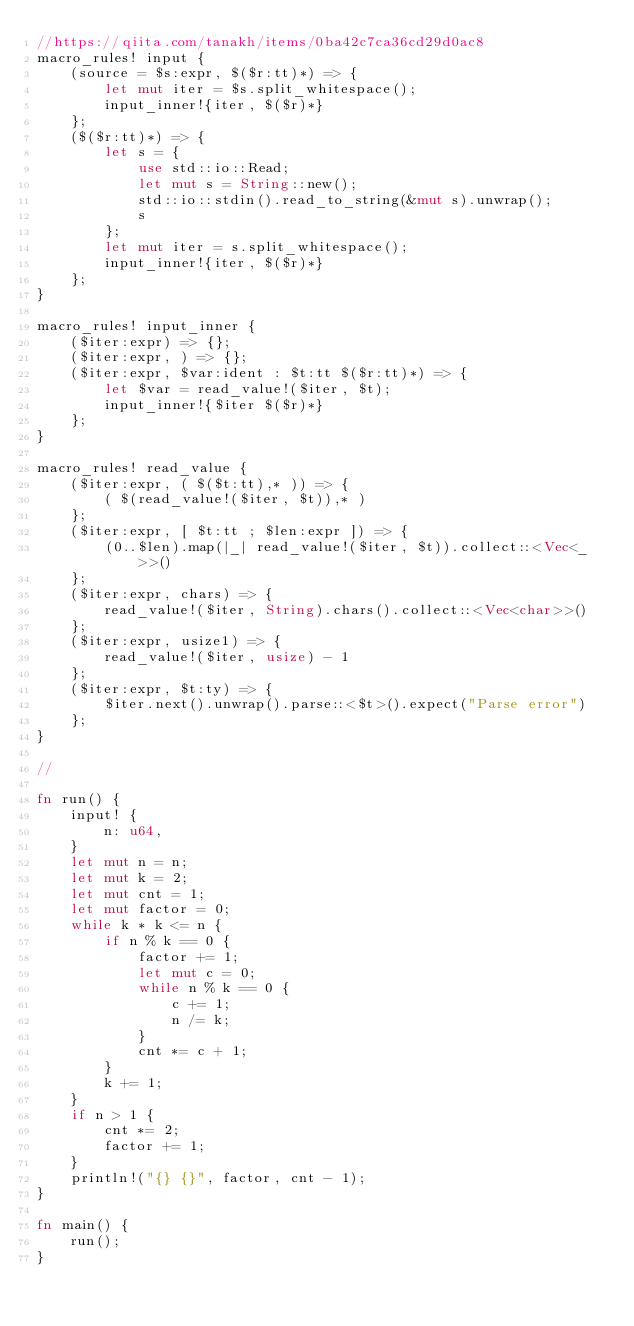Convert code to text. <code><loc_0><loc_0><loc_500><loc_500><_Rust_>//https://qiita.com/tanakh/items/0ba42c7ca36cd29d0ac8
macro_rules! input {
    (source = $s:expr, $($r:tt)*) => {
        let mut iter = $s.split_whitespace();
        input_inner!{iter, $($r)*}
    };
    ($($r:tt)*) => {
        let s = {
            use std::io::Read;
            let mut s = String::new();
            std::io::stdin().read_to_string(&mut s).unwrap();
            s
        };
        let mut iter = s.split_whitespace();
        input_inner!{iter, $($r)*}
    };
}

macro_rules! input_inner {
    ($iter:expr) => {};
    ($iter:expr, ) => {};
    ($iter:expr, $var:ident : $t:tt $($r:tt)*) => {
        let $var = read_value!($iter, $t);
        input_inner!{$iter $($r)*}
    };
}

macro_rules! read_value {
    ($iter:expr, ( $($t:tt),* )) => {
        ( $(read_value!($iter, $t)),* )
    };
    ($iter:expr, [ $t:tt ; $len:expr ]) => {
        (0..$len).map(|_| read_value!($iter, $t)).collect::<Vec<_>>()
    };
    ($iter:expr, chars) => {
        read_value!($iter, String).chars().collect::<Vec<char>>()
    };
    ($iter:expr, usize1) => {
        read_value!($iter, usize) - 1
    };
    ($iter:expr, $t:ty) => {
        $iter.next().unwrap().parse::<$t>().expect("Parse error")
    };
}

//

fn run() {
    input! {
        n: u64,
    }
    let mut n = n;
    let mut k = 2;
    let mut cnt = 1;
    let mut factor = 0;
    while k * k <= n {
        if n % k == 0 {
            factor += 1;
            let mut c = 0;
            while n % k == 0 {
                c += 1;
                n /= k;
            }
            cnt *= c + 1;
        }
        k += 1;
    }
    if n > 1 {
        cnt *= 2;
        factor += 1;
    }
    println!("{} {}", factor, cnt - 1);
}

fn main() {
    run();
}

</code> 